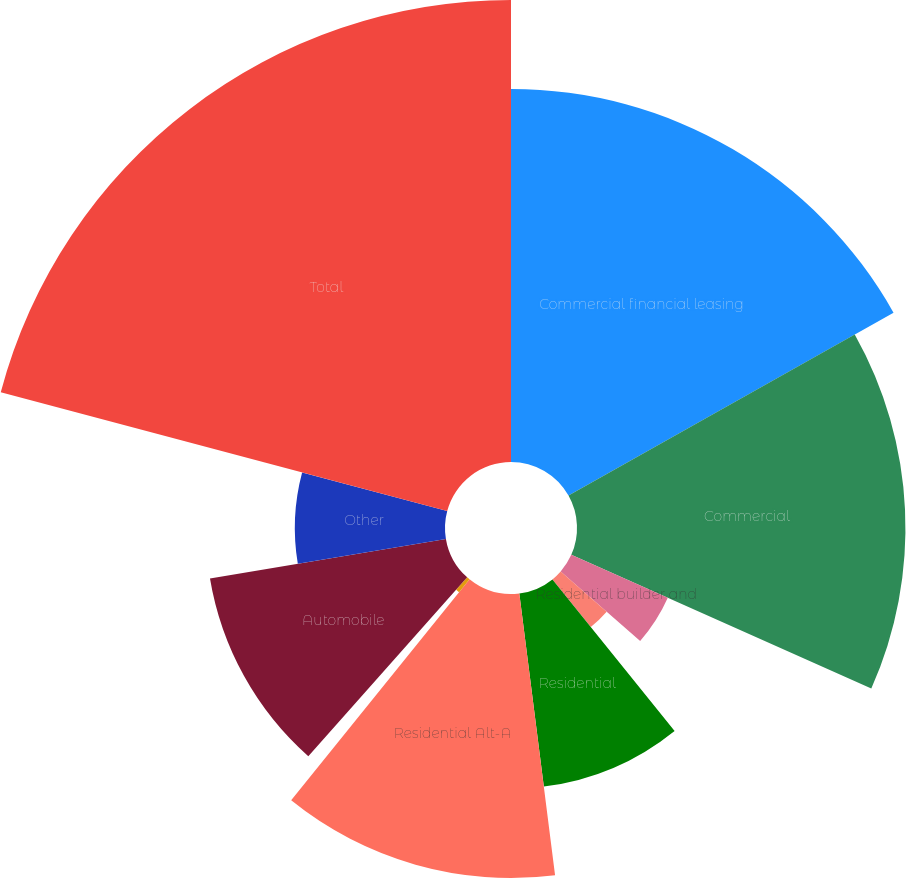Convert chart to OTSL. <chart><loc_0><loc_0><loc_500><loc_500><pie_chart><fcel>Commercial financial leasing<fcel>Commercial<fcel>Residential builder and<fcel>Other commercial construction<fcel>Residential<fcel>Residential Alt-A<fcel>Home equity lines and loans<fcel>Automobile<fcel>Other<fcel>Total<nl><fcel>16.84%<fcel>14.83%<fcel>4.77%<fcel>2.76%<fcel>8.79%<fcel>12.82%<fcel>0.75%<fcel>10.8%<fcel>6.78%<fcel>20.86%<nl></chart> 